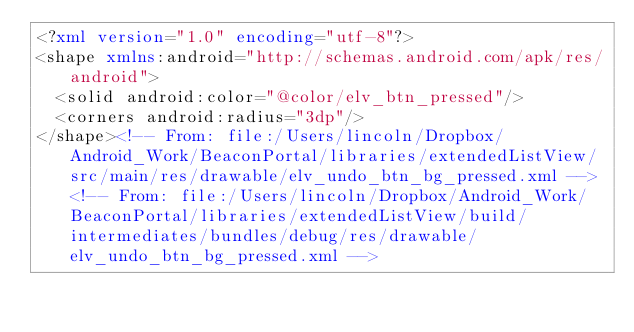Convert code to text. <code><loc_0><loc_0><loc_500><loc_500><_XML_><?xml version="1.0" encoding="utf-8"?>
<shape xmlns:android="http://schemas.android.com/apk/res/android">
	<solid android:color="@color/elv_btn_pressed"/>
	<corners android:radius="3dp"/>
</shape><!-- From: file:/Users/lincoln/Dropbox/Android_Work/BeaconPortal/libraries/extendedListView/src/main/res/drawable/elv_undo_btn_bg_pressed.xml --><!-- From: file:/Users/lincoln/Dropbox/Android_Work/BeaconPortal/libraries/extendedListView/build/intermediates/bundles/debug/res/drawable/elv_undo_btn_bg_pressed.xml --></code> 